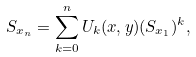<formula> <loc_0><loc_0><loc_500><loc_500>S _ { x _ { n } } = \sum _ { k = 0 } ^ { n } U _ { k } ( x , y ) ( S _ { x _ { 1 } } ) ^ { k } ,</formula> 